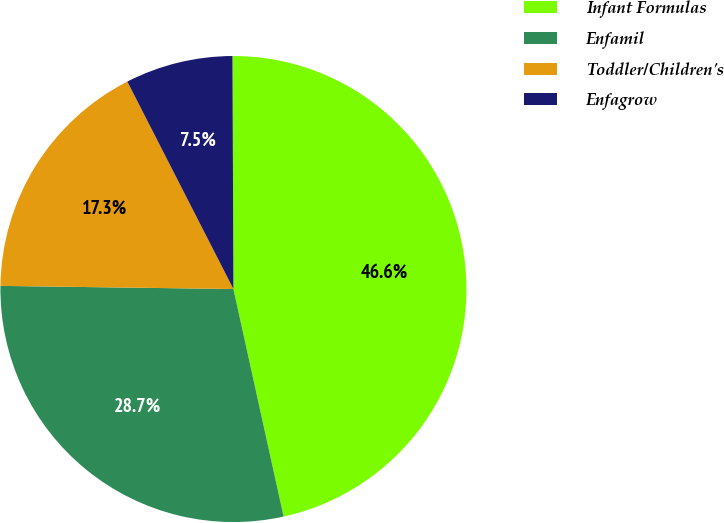<chart> <loc_0><loc_0><loc_500><loc_500><pie_chart><fcel>Infant Formulas<fcel>Enfamil<fcel>Toddler/Children's<fcel>Enfagrow<nl><fcel>46.61%<fcel>28.67%<fcel>17.26%<fcel>7.46%<nl></chart> 